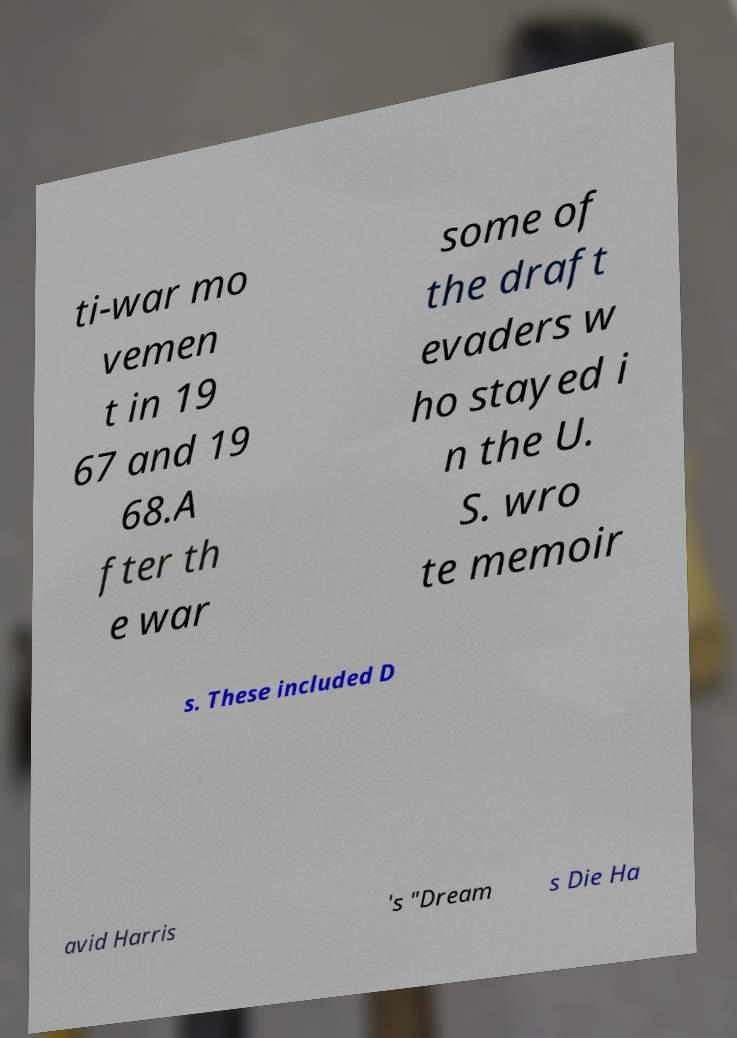For documentation purposes, I need the text within this image transcribed. Could you provide that? ti-war mo vemen t in 19 67 and 19 68.A fter th e war some of the draft evaders w ho stayed i n the U. S. wro te memoir s. These included D avid Harris 's "Dream s Die Ha 